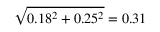Convert formula to latex. <formula><loc_0><loc_0><loc_500><loc_500>\sqrt { 0 . 1 8 ^ { 2 } + 0 . 2 5 ^ { 2 } } = 0 . 3 1</formula> 